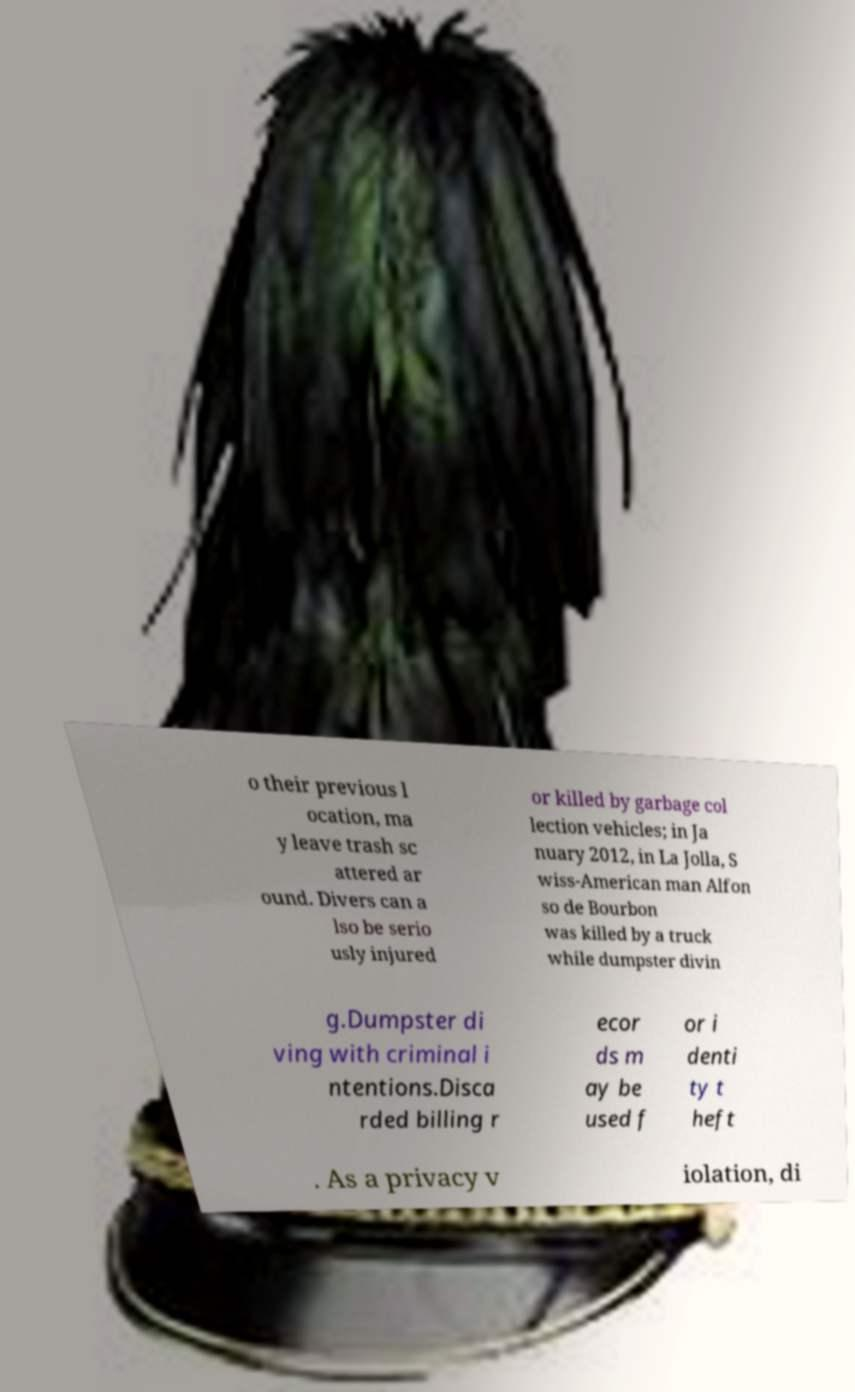Could you assist in decoding the text presented in this image and type it out clearly? o their previous l ocation, ma y leave trash sc attered ar ound. Divers can a lso be serio usly injured or killed by garbage col lection vehicles; in Ja nuary 2012, in La Jolla, S wiss-American man Alfon so de Bourbon was killed by a truck while dumpster divin g.Dumpster di ving with criminal i ntentions.Disca rded billing r ecor ds m ay be used f or i denti ty t heft . As a privacy v iolation, di 